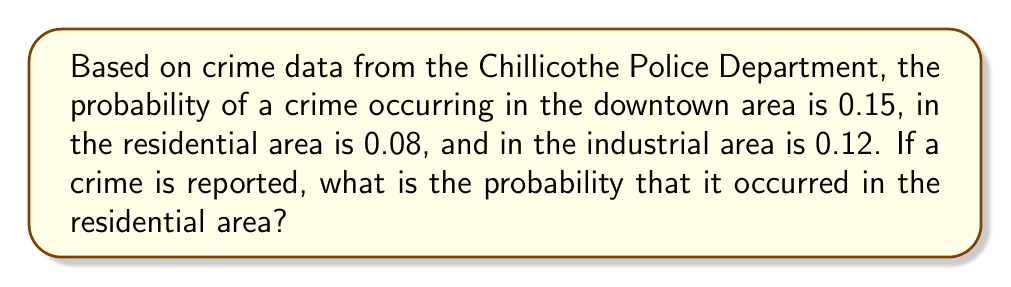Provide a solution to this math problem. To solve this problem, we'll use Bayes' Theorem. Let's define our events:

$R$: Crime occurred in the residential area
$D$: Crime occurred in the downtown area
$I$: Crime occurred in the industrial area

We're given:
$P(R) = 0.08$
$P(D) = 0.15$
$P(I) = 0.12$

Step 1: Calculate the total probability of a crime occurring.
$P(\text{Crime}) = P(R) + P(D) + P(I) = 0.08 + 0.15 + 0.12 = 0.35$

Step 2: Apply Bayes' Theorem to find the probability that a reported crime occurred in the residential area.

$$P(R|\text{Crime}) = \frac{P(R)}{P(\text{Crime})} = \frac{0.08}{0.35} = \frac{16}{70} = \frac{8}{35} \approx 0.2286$$

This can be interpreted as: given that a crime has occurred, there's a 22.86% chance it happened in the residential area.
Answer: The probability that a reported crime occurred in the residential area is $\frac{8}{35}$ or approximately 0.2286 (22.86%). 